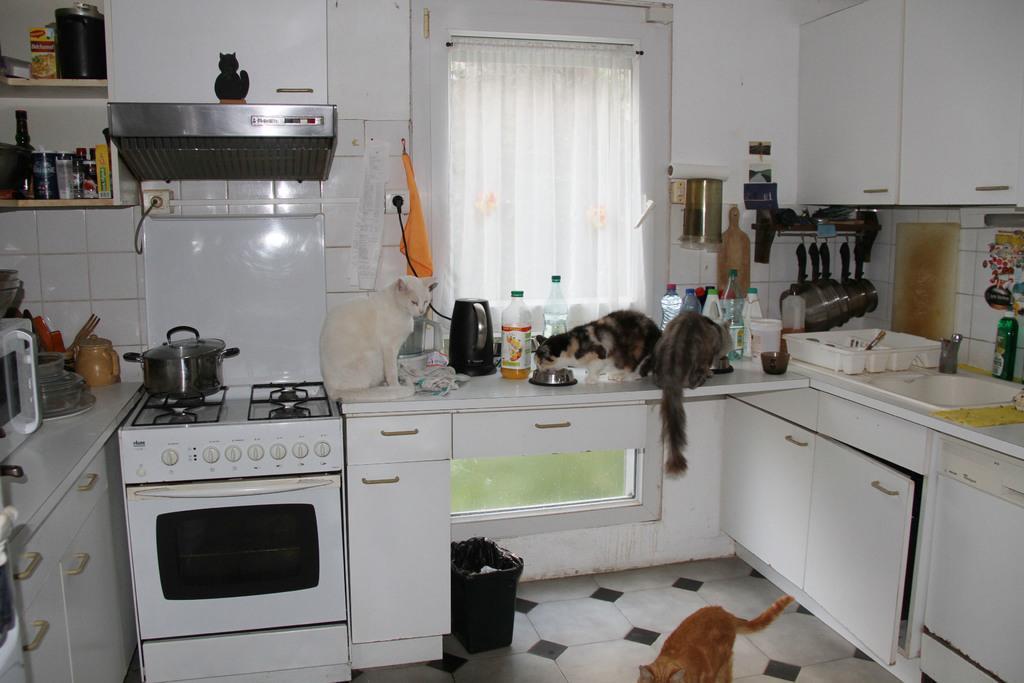Please provide a concise description of this image. In this image we can see cats are sitting on a table, gas stove, micro oven, bowl on a gas stove, bottles, electronic devices, cloth, food items on the racks, window, curtain, cupboards, chimney, plates, kettle and other objects. At the bottom we can see in, cat is standing on the floor and cupboard doors. 